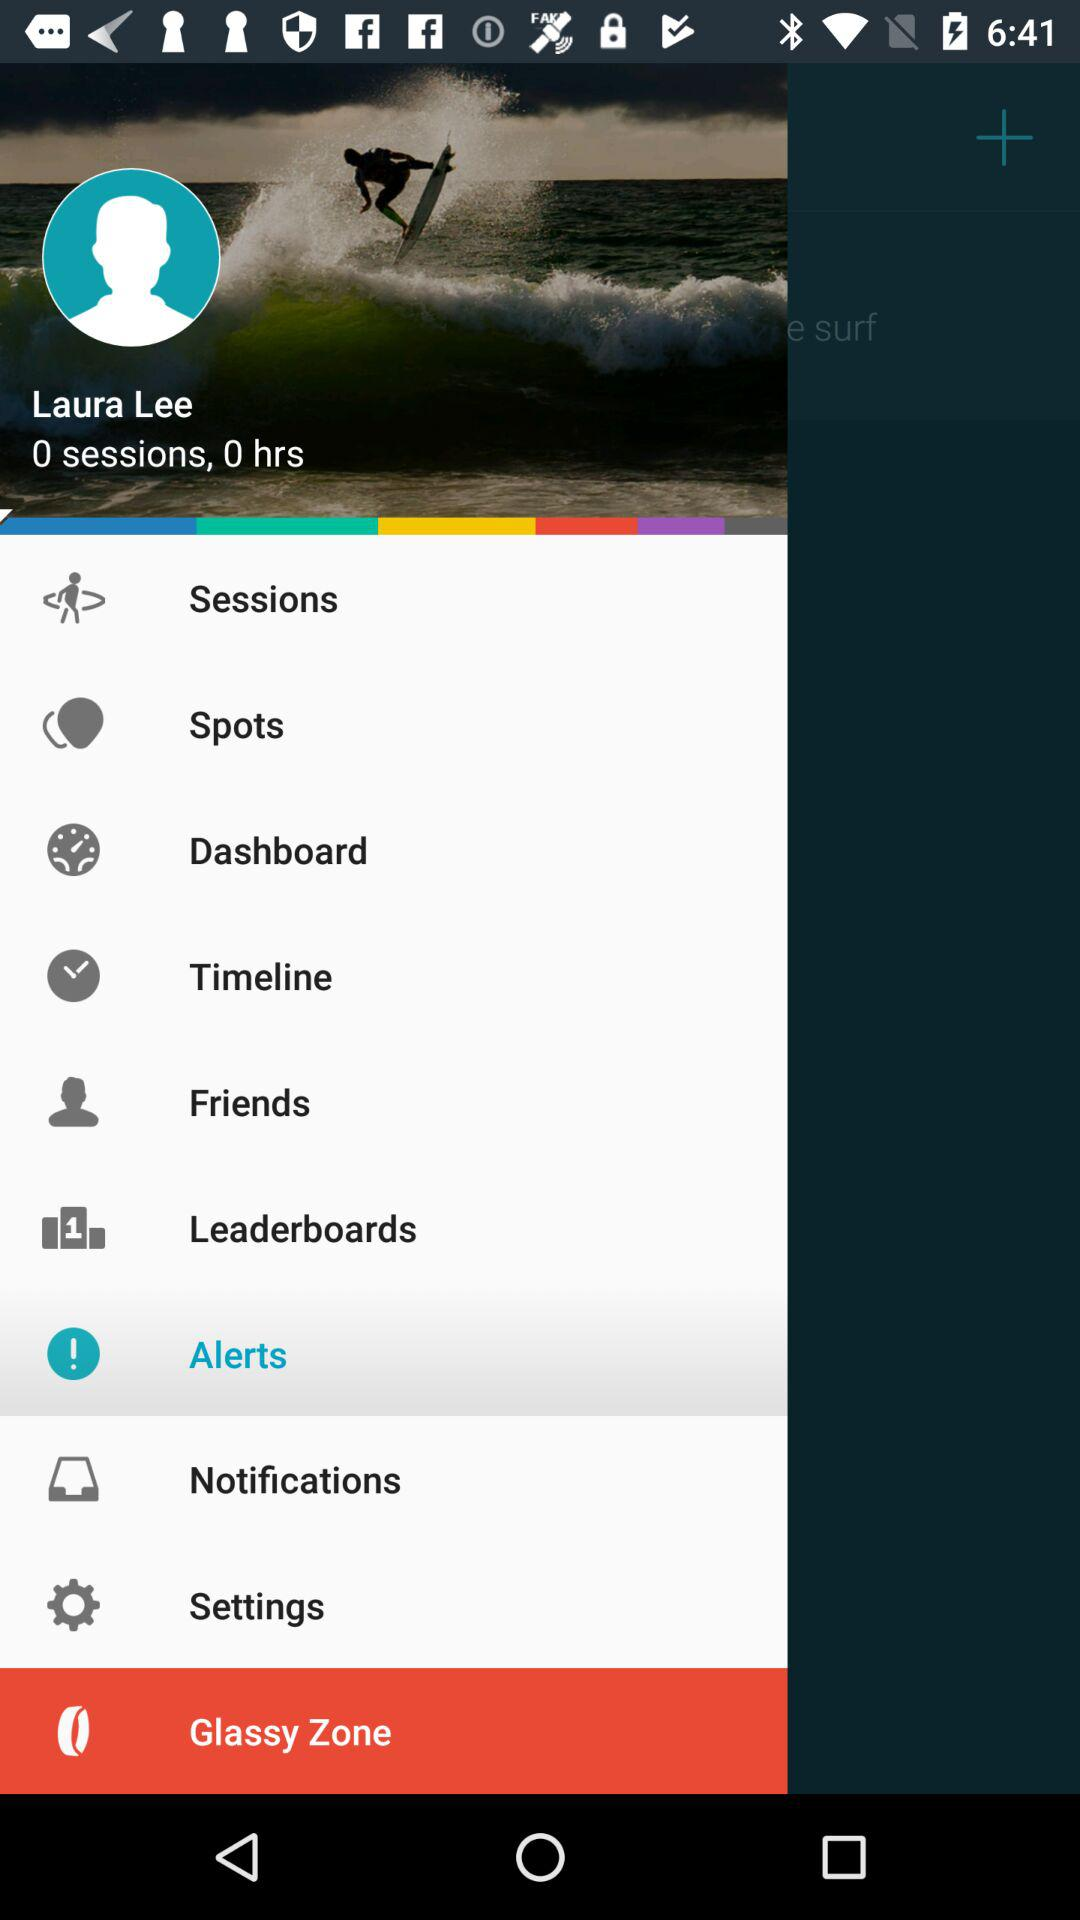What is the name of the user? The name of the user is Laura Lee. 